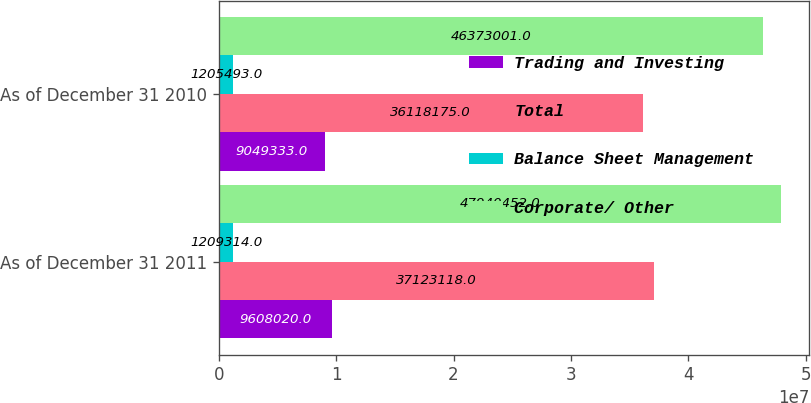<chart> <loc_0><loc_0><loc_500><loc_500><stacked_bar_chart><ecel><fcel>As of December 31 2011<fcel>As of December 31 2010<nl><fcel>Trading and Investing<fcel>9.60802e+06<fcel>9.04933e+06<nl><fcel>Total<fcel>3.71231e+07<fcel>3.61182e+07<nl><fcel>Balance Sheet Management<fcel>1.20931e+06<fcel>1.20549e+06<nl><fcel>Corporate/ Other<fcel>4.79405e+07<fcel>4.6373e+07<nl></chart> 